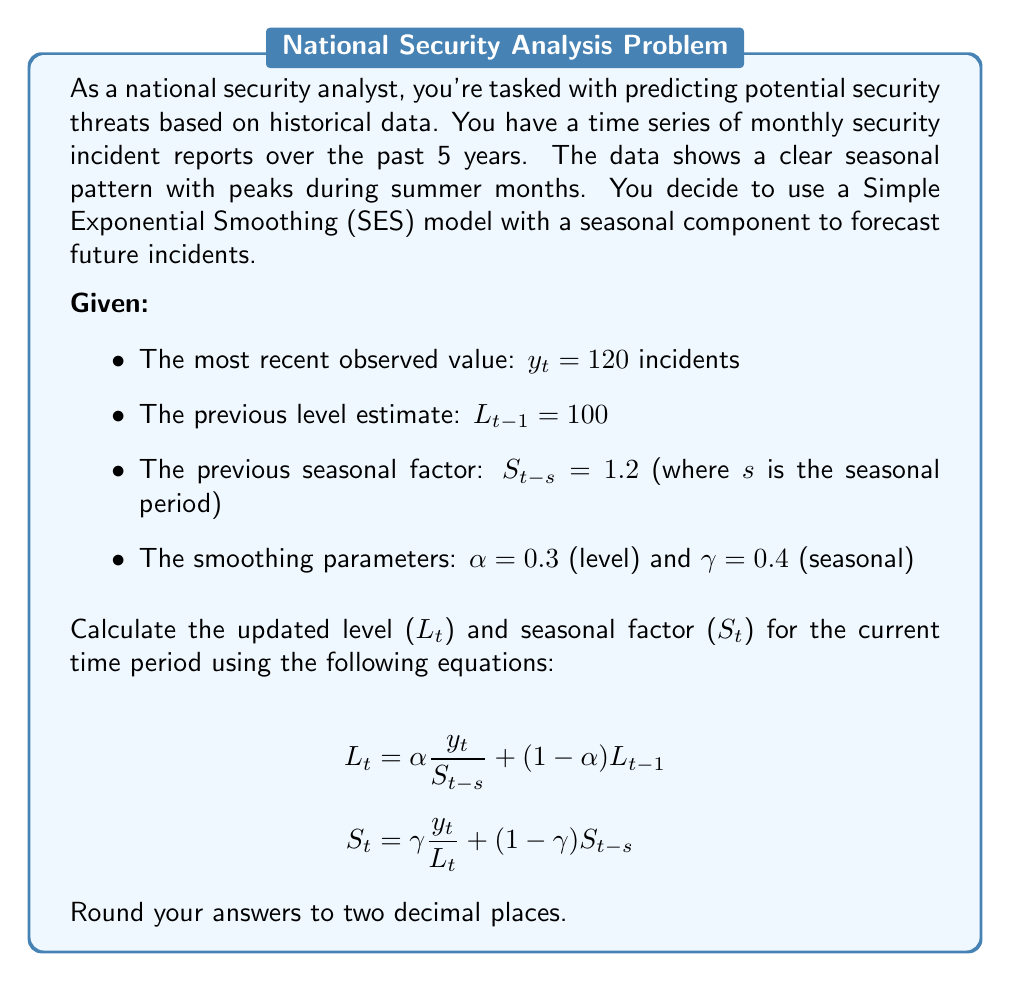Could you help me with this problem? Let's approach this step-by-step:

1) First, we'll calculate the updated level ($L_t$):

   $$L_t = \alpha \frac{y_t}{S_{t-s}} + (1-\alpha)L_{t-1}$$

   Substituting the given values:
   $$L_t = 0.3 \frac{120}{1.2} + (1-0.3)100$$

2) Let's solve the first part:
   $$0.3 \frac{120}{1.2} = 0.3 \times 100 = 30$$

3) Now the second part:
   $$(1-0.3)100 = 0.7 \times 100 = 70$$

4) Adding these together:
   $$L_t = 30 + 70 = 100$$

5) Next, we'll calculate the updated seasonal factor ($S_t$):

   $$S_t = \gamma \frac{y_t}{L_t} + (1-\gamma)S_{t-s}$$

   Substituting the given values and our calculated $L_t$:
   $$S_t = 0.4 \frac{120}{100} + (1-0.4)1.2$$

6) Let's solve the first part:
   $$0.4 \frac{120}{100} = 0.4 \times 1.2 = 0.48$$

7) Now the second part:
   $$(1-0.4)1.2 = 0.6 \times 1.2 = 0.72$$

8) Adding these together:
   $$S_t = 0.48 + 0.72 = 1.20$$

Therefore, the updated level ($L_t$) is 100.00 and the updated seasonal factor ($S_t$) is 1.20.
Answer: $L_t = 100.00$, $S_t = 1.20$ 